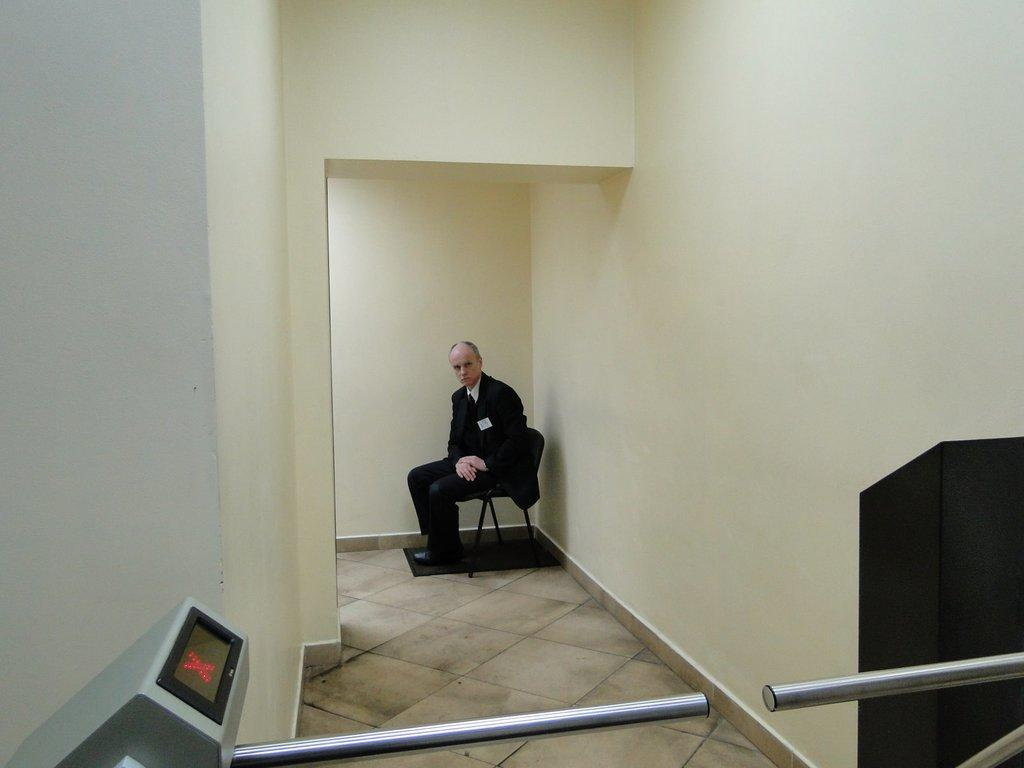What is located at the bottom of the image? There is a machine at the bottom of the image, along with rods and a black color object. Can you describe the background of the image? There is a wall and a mat in the background of the image, and a person is sitting on a chair. What type of egg is the person holding in the image? There is no egg present in the image; the person is sitting on a chair in the background. What type of collar is the machine wearing in the image? There is no collar present in the image; the machine is at the bottom of the image. 